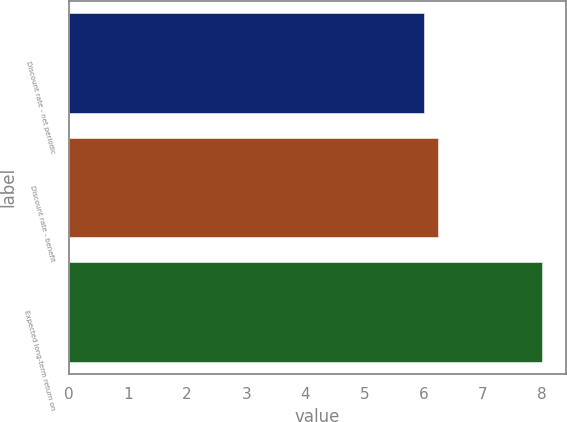<chart> <loc_0><loc_0><loc_500><loc_500><bar_chart><fcel>Discount rate - net periodic<fcel>Discount rate - benefit<fcel>Expected long-term return on<nl><fcel>6<fcel>6.25<fcel>8<nl></chart> 